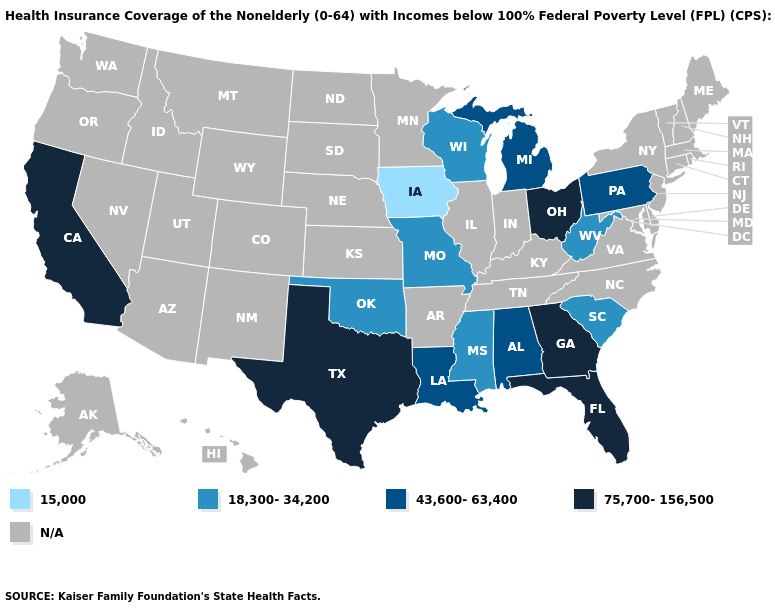Among the states that border Arizona , which have the highest value?
Write a very short answer. California. Name the states that have a value in the range 18,300-34,200?
Be succinct. Mississippi, Missouri, Oklahoma, South Carolina, West Virginia, Wisconsin. Does the first symbol in the legend represent the smallest category?
Quick response, please. Yes. What is the value of Ohio?
Short answer required. 75,700-156,500. Does Wisconsin have the highest value in the USA?
Give a very brief answer. No. Which states have the lowest value in the USA?
Give a very brief answer. Iowa. What is the lowest value in the South?
Give a very brief answer. 18,300-34,200. What is the highest value in the USA?
Keep it brief. 75,700-156,500. What is the value of New Hampshire?
Quick response, please. N/A. Name the states that have a value in the range 75,700-156,500?
Be succinct. California, Florida, Georgia, Ohio, Texas. What is the value of Nevada?
Be succinct. N/A. What is the highest value in the USA?
Quick response, please. 75,700-156,500. Among the states that border Texas , does Louisiana have the lowest value?
Write a very short answer. No. What is the value of Idaho?
Give a very brief answer. N/A. 